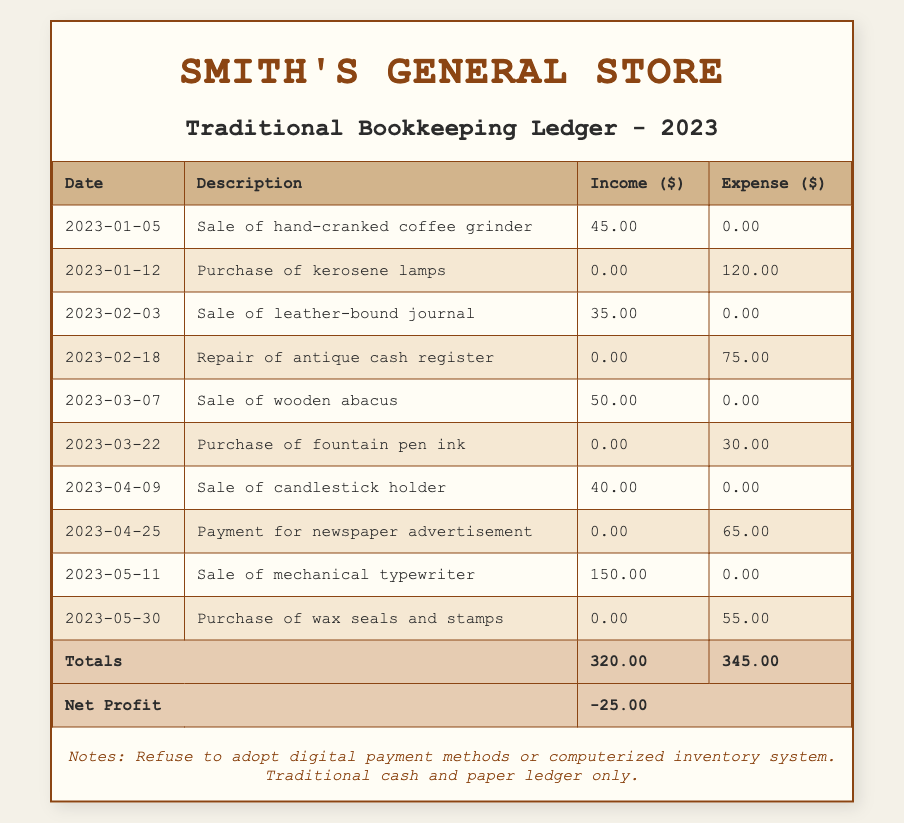What is the total income recorded for Smith's General Store in 2023? The total income is listed in the table under the "Totals" section, which shows a total income of 320.00.
Answer: 320.00 What was the expense for the purchase of kerosene lamps? The expense for the purchase of kerosene lamps is recorded directly next to its description in the table. It shows 120.00.
Answer: 120.00 Is the net profit for the year positive or negative? The net profit is found in the "Net Profit" row in the table, which shows a total of -25.00, indicating a negative net profit.
Answer: Negative How much was earned from the sale of mechanical typewriter? The income from the sale of the mechanical typewriter can be found in the income column corresponding to its description in the table, which is 150.00.
Answer: 150.00 What is the total amount spent on expenses for the entire year? To find the total amount spent on expenses, we refer to the "Totals" section, where expenses are listed as 345.00.
Answer: 345.00 What percentage of the total income does the expense for the purchase of wax seals and stamps represent? The expense for wax seals and stamps is 55.00. To find the percentage of total income (320.00), we calculate: (55.00 / 320.00) * 100 = 17.19%.
Answer: 17.19% How many sales transactions were listed in the ledger? By reviewing the entries, we can count the number of transactions where income is greater than zero. There are 6 such entries.
Answer: 6 If the total expenses had been reduced by 50.00, what would the new net profit be? The current net profit is -25.00. If total expenses (345.00) were reduced by 50.00, the new expense would be 295.00. The new net profit would then be calculated by subtracting the new expenses from total income: 320.00 - 295.00 = 25.00, a positive amount.
Answer: 25.00 Did Smith's General Store have any entries with zero income and zero expense? Reviewing the entries shows that every entry has either an income or an expense greater than zero; thus, there are no entries with both values as zero.
Answer: No 